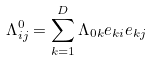Convert formula to latex. <formula><loc_0><loc_0><loc_500><loc_500>\Lambda _ { i j } ^ { 0 } = \sum _ { k = 1 } ^ { D } \Lambda _ { 0 k } e _ { k i } e _ { k j }</formula> 